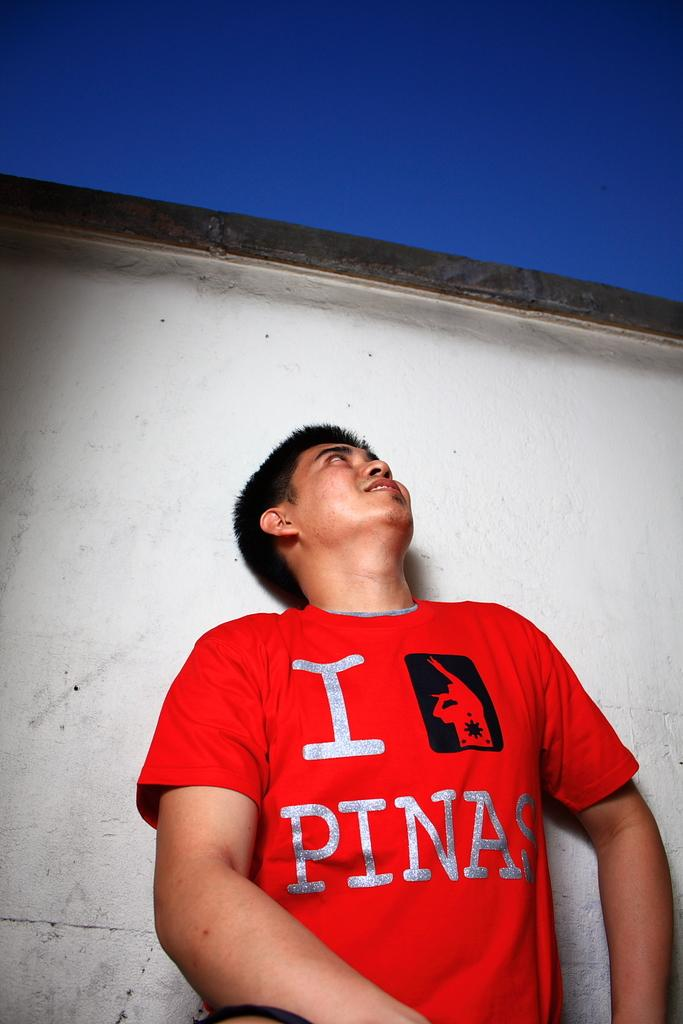<image>
Create a compact narrative representing the image presented. a boy looking up wearing a red tshirt with a I Pinas logo 